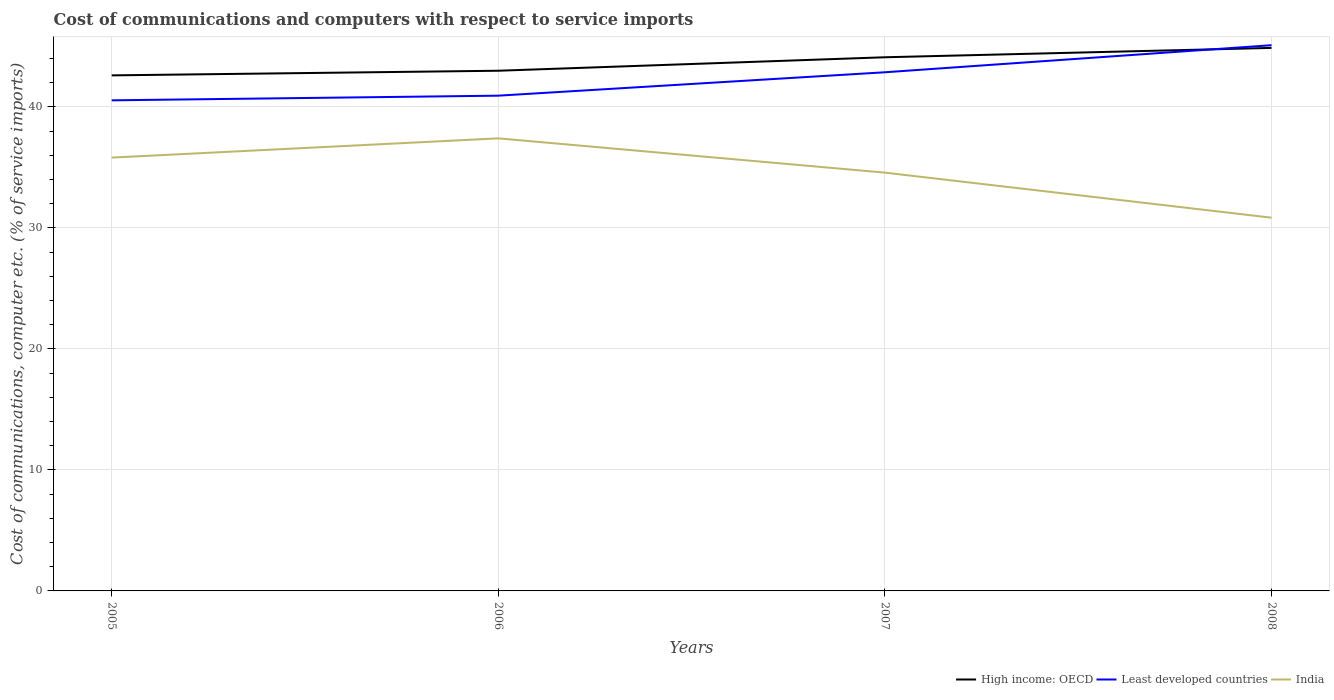How many different coloured lines are there?
Provide a short and direct response. 3. Does the line corresponding to High income: OECD intersect with the line corresponding to India?
Ensure brevity in your answer.  No. Is the number of lines equal to the number of legend labels?
Your response must be concise. Yes. Across all years, what is the maximum cost of communications and computers in Least developed countries?
Your answer should be very brief. 40.55. In which year was the cost of communications and computers in High income: OECD maximum?
Your answer should be very brief. 2005. What is the total cost of communications and computers in High income: OECD in the graph?
Your answer should be compact. -1.5. What is the difference between the highest and the second highest cost of communications and computers in Least developed countries?
Your answer should be very brief. 4.56. What is the difference between the highest and the lowest cost of communications and computers in Least developed countries?
Provide a succinct answer. 2. Is the cost of communications and computers in High income: OECD strictly greater than the cost of communications and computers in Least developed countries over the years?
Give a very brief answer. No. How many years are there in the graph?
Offer a terse response. 4. What is the difference between two consecutive major ticks on the Y-axis?
Keep it short and to the point. 10. Does the graph contain any zero values?
Your response must be concise. No. How are the legend labels stacked?
Your answer should be very brief. Horizontal. What is the title of the graph?
Make the answer very short. Cost of communications and computers with respect to service imports. Does "Iran" appear as one of the legend labels in the graph?
Provide a succinct answer. No. What is the label or title of the Y-axis?
Offer a terse response. Cost of communications, computer etc. (% of service imports). What is the Cost of communications, computer etc. (% of service imports) of High income: OECD in 2005?
Provide a short and direct response. 42.61. What is the Cost of communications, computer etc. (% of service imports) of Least developed countries in 2005?
Give a very brief answer. 40.55. What is the Cost of communications, computer etc. (% of service imports) of India in 2005?
Offer a terse response. 35.82. What is the Cost of communications, computer etc. (% of service imports) of High income: OECD in 2006?
Your response must be concise. 43. What is the Cost of communications, computer etc. (% of service imports) in Least developed countries in 2006?
Provide a short and direct response. 40.94. What is the Cost of communications, computer etc. (% of service imports) in India in 2006?
Make the answer very short. 37.41. What is the Cost of communications, computer etc. (% of service imports) of High income: OECD in 2007?
Make the answer very short. 44.11. What is the Cost of communications, computer etc. (% of service imports) of Least developed countries in 2007?
Give a very brief answer. 42.87. What is the Cost of communications, computer etc. (% of service imports) of India in 2007?
Give a very brief answer. 34.57. What is the Cost of communications, computer etc. (% of service imports) of High income: OECD in 2008?
Give a very brief answer. 44.88. What is the Cost of communications, computer etc. (% of service imports) of Least developed countries in 2008?
Provide a short and direct response. 45.11. What is the Cost of communications, computer etc. (% of service imports) of India in 2008?
Your answer should be compact. 30.85. Across all years, what is the maximum Cost of communications, computer etc. (% of service imports) in High income: OECD?
Offer a terse response. 44.88. Across all years, what is the maximum Cost of communications, computer etc. (% of service imports) of Least developed countries?
Offer a very short reply. 45.11. Across all years, what is the maximum Cost of communications, computer etc. (% of service imports) of India?
Ensure brevity in your answer.  37.41. Across all years, what is the minimum Cost of communications, computer etc. (% of service imports) in High income: OECD?
Your response must be concise. 42.61. Across all years, what is the minimum Cost of communications, computer etc. (% of service imports) in Least developed countries?
Make the answer very short. 40.55. Across all years, what is the minimum Cost of communications, computer etc. (% of service imports) of India?
Offer a terse response. 30.85. What is the total Cost of communications, computer etc. (% of service imports) of High income: OECD in the graph?
Your response must be concise. 174.61. What is the total Cost of communications, computer etc. (% of service imports) in Least developed countries in the graph?
Make the answer very short. 169.47. What is the total Cost of communications, computer etc. (% of service imports) in India in the graph?
Offer a terse response. 138.65. What is the difference between the Cost of communications, computer etc. (% of service imports) in High income: OECD in 2005 and that in 2006?
Provide a short and direct response. -0.38. What is the difference between the Cost of communications, computer etc. (% of service imports) of Least developed countries in 2005 and that in 2006?
Your response must be concise. -0.39. What is the difference between the Cost of communications, computer etc. (% of service imports) of India in 2005 and that in 2006?
Ensure brevity in your answer.  -1.59. What is the difference between the Cost of communications, computer etc. (% of service imports) in High income: OECD in 2005 and that in 2007?
Offer a terse response. -1.5. What is the difference between the Cost of communications, computer etc. (% of service imports) in Least developed countries in 2005 and that in 2007?
Provide a succinct answer. -2.32. What is the difference between the Cost of communications, computer etc. (% of service imports) in India in 2005 and that in 2007?
Provide a short and direct response. 1.24. What is the difference between the Cost of communications, computer etc. (% of service imports) in High income: OECD in 2005 and that in 2008?
Give a very brief answer. -2.27. What is the difference between the Cost of communications, computer etc. (% of service imports) in Least developed countries in 2005 and that in 2008?
Ensure brevity in your answer.  -4.56. What is the difference between the Cost of communications, computer etc. (% of service imports) of India in 2005 and that in 2008?
Offer a very short reply. 4.97. What is the difference between the Cost of communications, computer etc. (% of service imports) in High income: OECD in 2006 and that in 2007?
Your answer should be compact. -1.11. What is the difference between the Cost of communications, computer etc. (% of service imports) of Least developed countries in 2006 and that in 2007?
Offer a terse response. -1.93. What is the difference between the Cost of communications, computer etc. (% of service imports) in India in 2006 and that in 2007?
Provide a succinct answer. 2.83. What is the difference between the Cost of communications, computer etc. (% of service imports) of High income: OECD in 2006 and that in 2008?
Provide a short and direct response. -1.89. What is the difference between the Cost of communications, computer etc. (% of service imports) in Least developed countries in 2006 and that in 2008?
Ensure brevity in your answer.  -4.17. What is the difference between the Cost of communications, computer etc. (% of service imports) in India in 2006 and that in 2008?
Your answer should be compact. 6.56. What is the difference between the Cost of communications, computer etc. (% of service imports) in High income: OECD in 2007 and that in 2008?
Offer a terse response. -0.77. What is the difference between the Cost of communications, computer etc. (% of service imports) of Least developed countries in 2007 and that in 2008?
Offer a terse response. -2.24. What is the difference between the Cost of communications, computer etc. (% of service imports) in India in 2007 and that in 2008?
Ensure brevity in your answer.  3.72. What is the difference between the Cost of communications, computer etc. (% of service imports) in High income: OECD in 2005 and the Cost of communications, computer etc. (% of service imports) in Least developed countries in 2006?
Your answer should be very brief. 1.68. What is the difference between the Cost of communications, computer etc. (% of service imports) of High income: OECD in 2005 and the Cost of communications, computer etc. (% of service imports) of India in 2006?
Your answer should be compact. 5.21. What is the difference between the Cost of communications, computer etc. (% of service imports) of Least developed countries in 2005 and the Cost of communications, computer etc. (% of service imports) of India in 2006?
Give a very brief answer. 3.14. What is the difference between the Cost of communications, computer etc. (% of service imports) in High income: OECD in 2005 and the Cost of communications, computer etc. (% of service imports) in Least developed countries in 2007?
Ensure brevity in your answer.  -0.26. What is the difference between the Cost of communications, computer etc. (% of service imports) in High income: OECD in 2005 and the Cost of communications, computer etc. (% of service imports) in India in 2007?
Provide a short and direct response. 8.04. What is the difference between the Cost of communications, computer etc. (% of service imports) in Least developed countries in 2005 and the Cost of communications, computer etc. (% of service imports) in India in 2007?
Give a very brief answer. 5.98. What is the difference between the Cost of communications, computer etc. (% of service imports) of High income: OECD in 2005 and the Cost of communications, computer etc. (% of service imports) of Least developed countries in 2008?
Your response must be concise. -2.49. What is the difference between the Cost of communications, computer etc. (% of service imports) of High income: OECD in 2005 and the Cost of communications, computer etc. (% of service imports) of India in 2008?
Your response must be concise. 11.76. What is the difference between the Cost of communications, computer etc. (% of service imports) in Least developed countries in 2005 and the Cost of communications, computer etc. (% of service imports) in India in 2008?
Provide a succinct answer. 9.7. What is the difference between the Cost of communications, computer etc. (% of service imports) in High income: OECD in 2006 and the Cost of communications, computer etc. (% of service imports) in Least developed countries in 2007?
Offer a terse response. 0.13. What is the difference between the Cost of communications, computer etc. (% of service imports) in High income: OECD in 2006 and the Cost of communications, computer etc. (% of service imports) in India in 2007?
Ensure brevity in your answer.  8.42. What is the difference between the Cost of communications, computer etc. (% of service imports) in Least developed countries in 2006 and the Cost of communications, computer etc. (% of service imports) in India in 2007?
Keep it short and to the point. 6.36. What is the difference between the Cost of communications, computer etc. (% of service imports) in High income: OECD in 2006 and the Cost of communications, computer etc. (% of service imports) in Least developed countries in 2008?
Offer a very short reply. -2.11. What is the difference between the Cost of communications, computer etc. (% of service imports) in High income: OECD in 2006 and the Cost of communications, computer etc. (% of service imports) in India in 2008?
Keep it short and to the point. 12.15. What is the difference between the Cost of communications, computer etc. (% of service imports) in Least developed countries in 2006 and the Cost of communications, computer etc. (% of service imports) in India in 2008?
Offer a terse response. 10.09. What is the difference between the Cost of communications, computer etc. (% of service imports) of High income: OECD in 2007 and the Cost of communications, computer etc. (% of service imports) of Least developed countries in 2008?
Your answer should be very brief. -1. What is the difference between the Cost of communications, computer etc. (% of service imports) of High income: OECD in 2007 and the Cost of communications, computer etc. (% of service imports) of India in 2008?
Your response must be concise. 13.26. What is the difference between the Cost of communications, computer etc. (% of service imports) in Least developed countries in 2007 and the Cost of communications, computer etc. (% of service imports) in India in 2008?
Ensure brevity in your answer.  12.02. What is the average Cost of communications, computer etc. (% of service imports) in High income: OECD per year?
Keep it short and to the point. 43.65. What is the average Cost of communications, computer etc. (% of service imports) of Least developed countries per year?
Provide a succinct answer. 42.37. What is the average Cost of communications, computer etc. (% of service imports) of India per year?
Ensure brevity in your answer.  34.66. In the year 2005, what is the difference between the Cost of communications, computer etc. (% of service imports) in High income: OECD and Cost of communications, computer etc. (% of service imports) in Least developed countries?
Your response must be concise. 2.06. In the year 2005, what is the difference between the Cost of communications, computer etc. (% of service imports) in High income: OECD and Cost of communications, computer etc. (% of service imports) in India?
Your answer should be very brief. 6.8. In the year 2005, what is the difference between the Cost of communications, computer etc. (% of service imports) of Least developed countries and Cost of communications, computer etc. (% of service imports) of India?
Provide a short and direct response. 4.73. In the year 2006, what is the difference between the Cost of communications, computer etc. (% of service imports) of High income: OECD and Cost of communications, computer etc. (% of service imports) of Least developed countries?
Keep it short and to the point. 2.06. In the year 2006, what is the difference between the Cost of communications, computer etc. (% of service imports) in High income: OECD and Cost of communications, computer etc. (% of service imports) in India?
Your answer should be compact. 5.59. In the year 2006, what is the difference between the Cost of communications, computer etc. (% of service imports) in Least developed countries and Cost of communications, computer etc. (% of service imports) in India?
Your answer should be very brief. 3.53. In the year 2007, what is the difference between the Cost of communications, computer etc. (% of service imports) in High income: OECD and Cost of communications, computer etc. (% of service imports) in Least developed countries?
Your answer should be very brief. 1.24. In the year 2007, what is the difference between the Cost of communications, computer etc. (% of service imports) in High income: OECD and Cost of communications, computer etc. (% of service imports) in India?
Your response must be concise. 9.54. In the year 2007, what is the difference between the Cost of communications, computer etc. (% of service imports) in Least developed countries and Cost of communications, computer etc. (% of service imports) in India?
Offer a very short reply. 8.3. In the year 2008, what is the difference between the Cost of communications, computer etc. (% of service imports) in High income: OECD and Cost of communications, computer etc. (% of service imports) in Least developed countries?
Your answer should be very brief. -0.22. In the year 2008, what is the difference between the Cost of communications, computer etc. (% of service imports) of High income: OECD and Cost of communications, computer etc. (% of service imports) of India?
Provide a succinct answer. 14.03. In the year 2008, what is the difference between the Cost of communications, computer etc. (% of service imports) of Least developed countries and Cost of communications, computer etc. (% of service imports) of India?
Offer a very short reply. 14.26. What is the ratio of the Cost of communications, computer etc. (% of service imports) of Least developed countries in 2005 to that in 2006?
Offer a terse response. 0.99. What is the ratio of the Cost of communications, computer etc. (% of service imports) of India in 2005 to that in 2006?
Offer a terse response. 0.96. What is the ratio of the Cost of communications, computer etc. (% of service imports) in High income: OECD in 2005 to that in 2007?
Ensure brevity in your answer.  0.97. What is the ratio of the Cost of communications, computer etc. (% of service imports) of Least developed countries in 2005 to that in 2007?
Offer a terse response. 0.95. What is the ratio of the Cost of communications, computer etc. (% of service imports) in India in 2005 to that in 2007?
Keep it short and to the point. 1.04. What is the ratio of the Cost of communications, computer etc. (% of service imports) in High income: OECD in 2005 to that in 2008?
Give a very brief answer. 0.95. What is the ratio of the Cost of communications, computer etc. (% of service imports) of Least developed countries in 2005 to that in 2008?
Give a very brief answer. 0.9. What is the ratio of the Cost of communications, computer etc. (% of service imports) of India in 2005 to that in 2008?
Your response must be concise. 1.16. What is the ratio of the Cost of communications, computer etc. (% of service imports) in High income: OECD in 2006 to that in 2007?
Keep it short and to the point. 0.97. What is the ratio of the Cost of communications, computer etc. (% of service imports) in Least developed countries in 2006 to that in 2007?
Your answer should be compact. 0.95. What is the ratio of the Cost of communications, computer etc. (% of service imports) in India in 2006 to that in 2007?
Provide a short and direct response. 1.08. What is the ratio of the Cost of communications, computer etc. (% of service imports) of High income: OECD in 2006 to that in 2008?
Your answer should be compact. 0.96. What is the ratio of the Cost of communications, computer etc. (% of service imports) in Least developed countries in 2006 to that in 2008?
Make the answer very short. 0.91. What is the ratio of the Cost of communications, computer etc. (% of service imports) of India in 2006 to that in 2008?
Your answer should be very brief. 1.21. What is the ratio of the Cost of communications, computer etc. (% of service imports) of High income: OECD in 2007 to that in 2008?
Your answer should be compact. 0.98. What is the ratio of the Cost of communications, computer etc. (% of service imports) of Least developed countries in 2007 to that in 2008?
Offer a terse response. 0.95. What is the ratio of the Cost of communications, computer etc. (% of service imports) in India in 2007 to that in 2008?
Keep it short and to the point. 1.12. What is the difference between the highest and the second highest Cost of communications, computer etc. (% of service imports) of High income: OECD?
Offer a very short reply. 0.77. What is the difference between the highest and the second highest Cost of communications, computer etc. (% of service imports) in Least developed countries?
Provide a short and direct response. 2.24. What is the difference between the highest and the second highest Cost of communications, computer etc. (% of service imports) in India?
Make the answer very short. 1.59. What is the difference between the highest and the lowest Cost of communications, computer etc. (% of service imports) of High income: OECD?
Your answer should be compact. 2.27. What is the difference between the highest and the lowest Cost of communications, computer etc. (% of service imports) of Least developed countries?
Your answer should be compact. 4.56. What is the difference between the highest and the lowest Cost of communications, computer etc. (% of service imports) in India?
Provide a short and direct response. 6.56. 